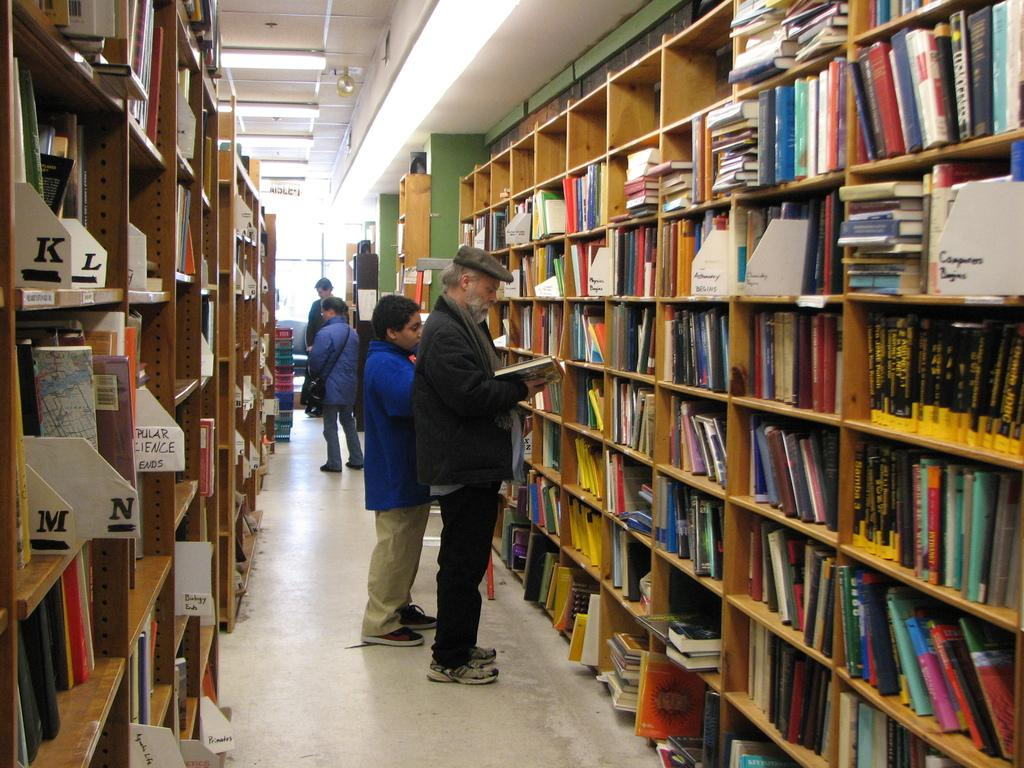Provide a one-sentence caption for the provided image. Rows of bookshelves are tagged with letters beginning with K and L on the left side. 